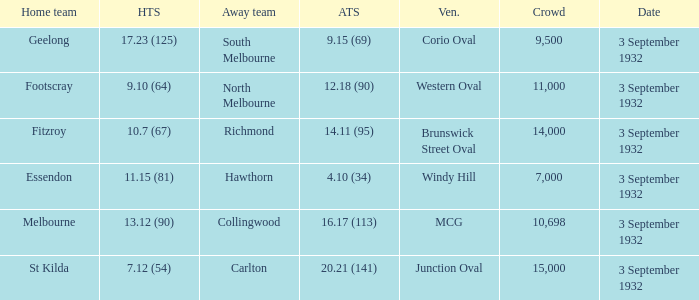What is the Home team score for the Away team of North Melbourne? 9.10 (64). 